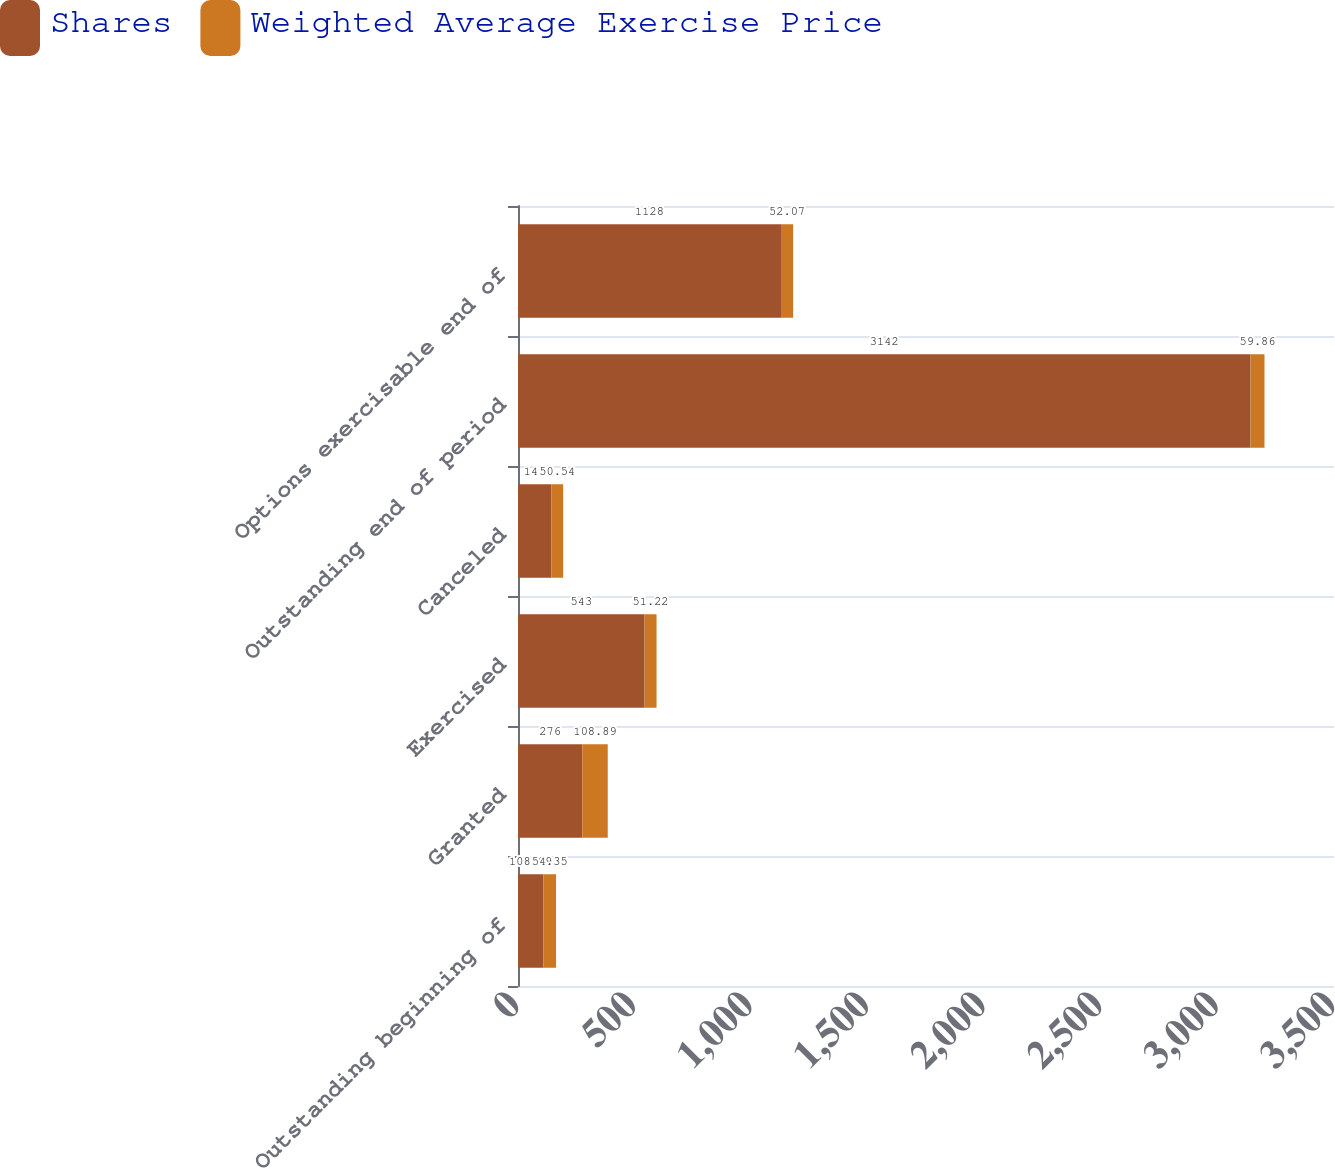Convert chart. <chart><loc_0><loc_0><loc_500><loc_500><stacked_bar_chart><ecel><fcel>Outstanding beginning of<fcel>Granted<fcel>Exercised<fcel>Canceled<fcel>Outstanding end of period<fcel>Options exercisable end of<nl><fcel>Shares<fcel>108.89<fcel>276<fcel>543<fcel>143<fcel>3142<fcel>1128<nl><fcel>Weighted Average Exercise Price<fcel>54.35<fcel>108.89<fcel>51.22<fcel>50.54<fcel>59.86<fcel>52.07<nl></chart> 